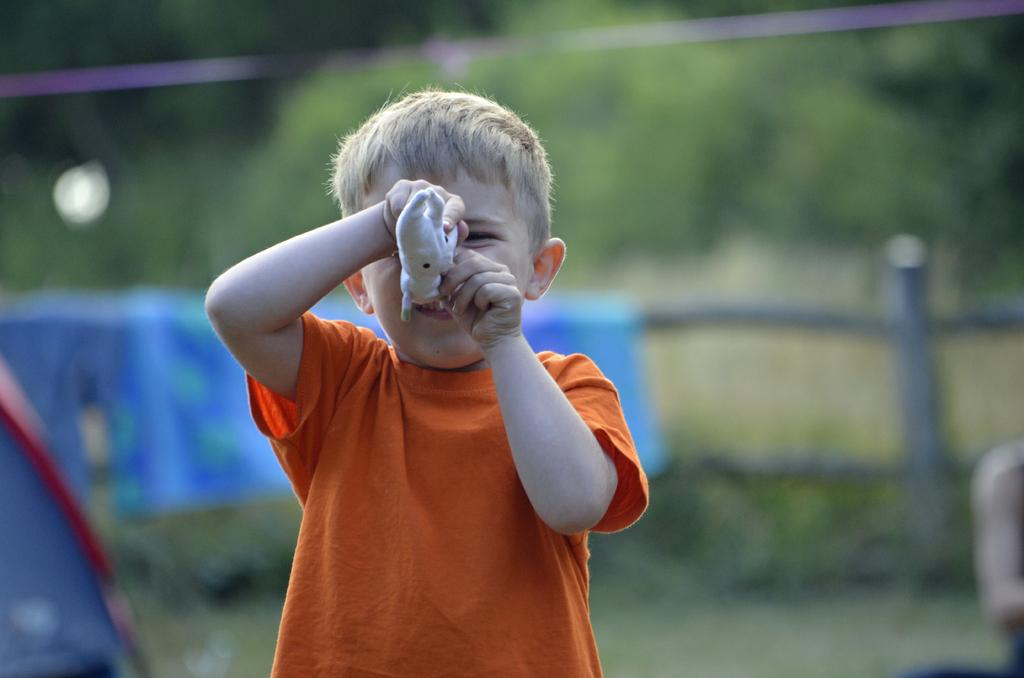What is the main subject of the image? There is a boy standing in the image. What is the boy holding in his hands? The boy is holding an object in his hands. What can be seen in the background of the image? There is a blue color object and trees in the background of the image. What type of vegetation is visible in the background? There are plants in the background of the image. What type of tank can be seen in the image? There is no tank present in the image. Can you describe the taste of the object the boy is holding in the image? The taste of the object cannot be determined from the image, as taste is not a visual characteristic. 